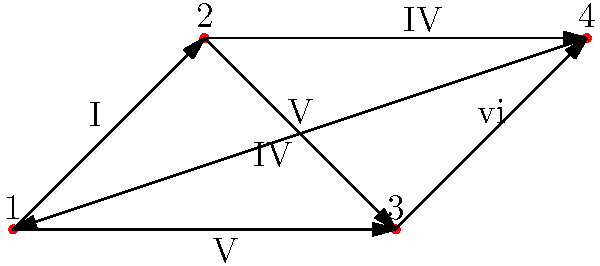In this directed graph representing chord progressions, each vertex represents a chord, and each edge represents a transition between chords. Given that the graph shows a classic rock progression, what is the maximum number of unique 4-chord progressions that can be played without repeating any chord? To solve this, let's follow these steps:

1) First, we need to understand what the question is asking. We're looking for 4-chord progressions where no chord is repeated.

2) In graph theory, this is equivalent to finding the number of simple paths of length 3 (4 vertices, 3 edges) in the directed graph.

3) Let's count the possible progressions starting from each vertex:

   From vertex 1:
   1-2-3-4
   1-2-4
   1-3-4
   1-4

   From vertex 2:
   2-3-4-1
   2-4-1

   From vertex 3:
   3-4-1-2

   From vertex 4:
   4-1-2-3
   4-1-3

4) Counting these up, we see that there are 9 possible progressions in total.

5) However, the question asks for the maximum number of unique 4-chord progressions. The progressions 1-2-4 and 4-1-3 only have 3 chords, so we exclude these.

6) This leaves us with 7 valid 4-chord progressions.

Therefore, the maximum number of unique 4-chord progressions that can be played without repeating any chord is 7.
Answer: 7 